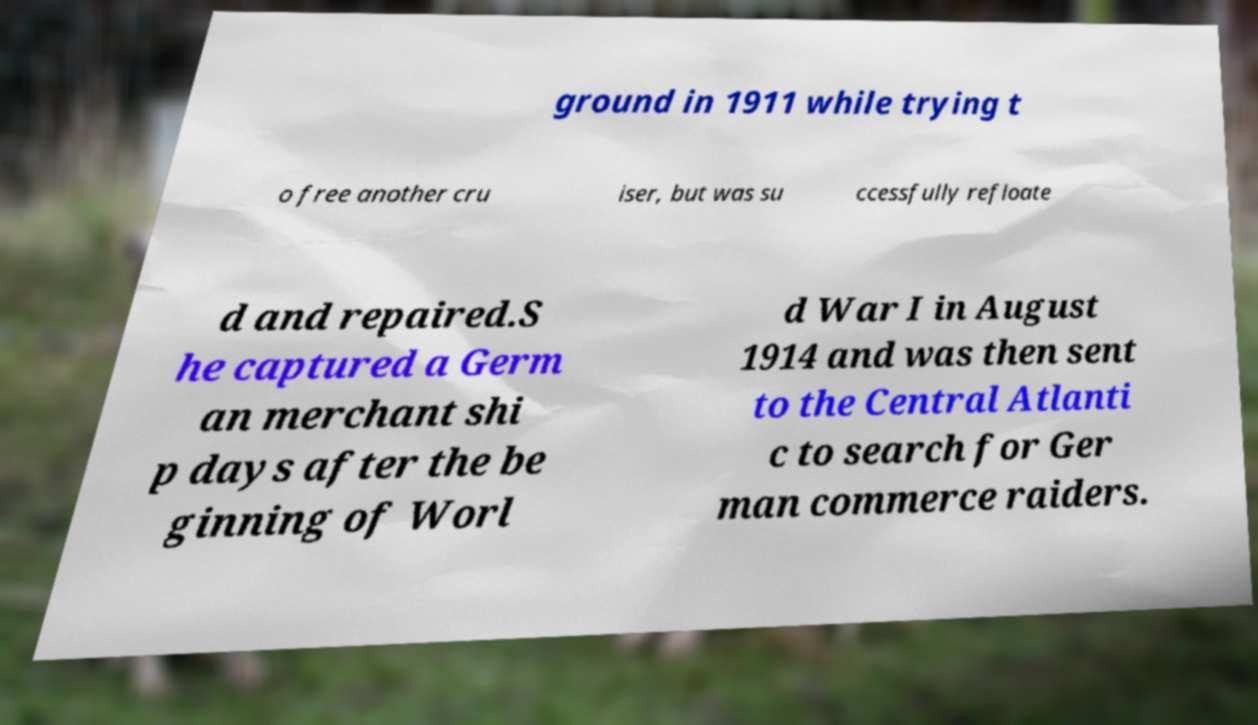For documentation purposes, I need the text within this image transcribed. Could you provide that? ground in 1911 while trying t o free another cru iser, but was su ccessfully refloate d and repaired.S he captured a Germ an merchant shi p days after the be ginning of Worl d War I in August 1914 and was then sent to the Central Atlanti c to search for Ger man commerce raiders. 